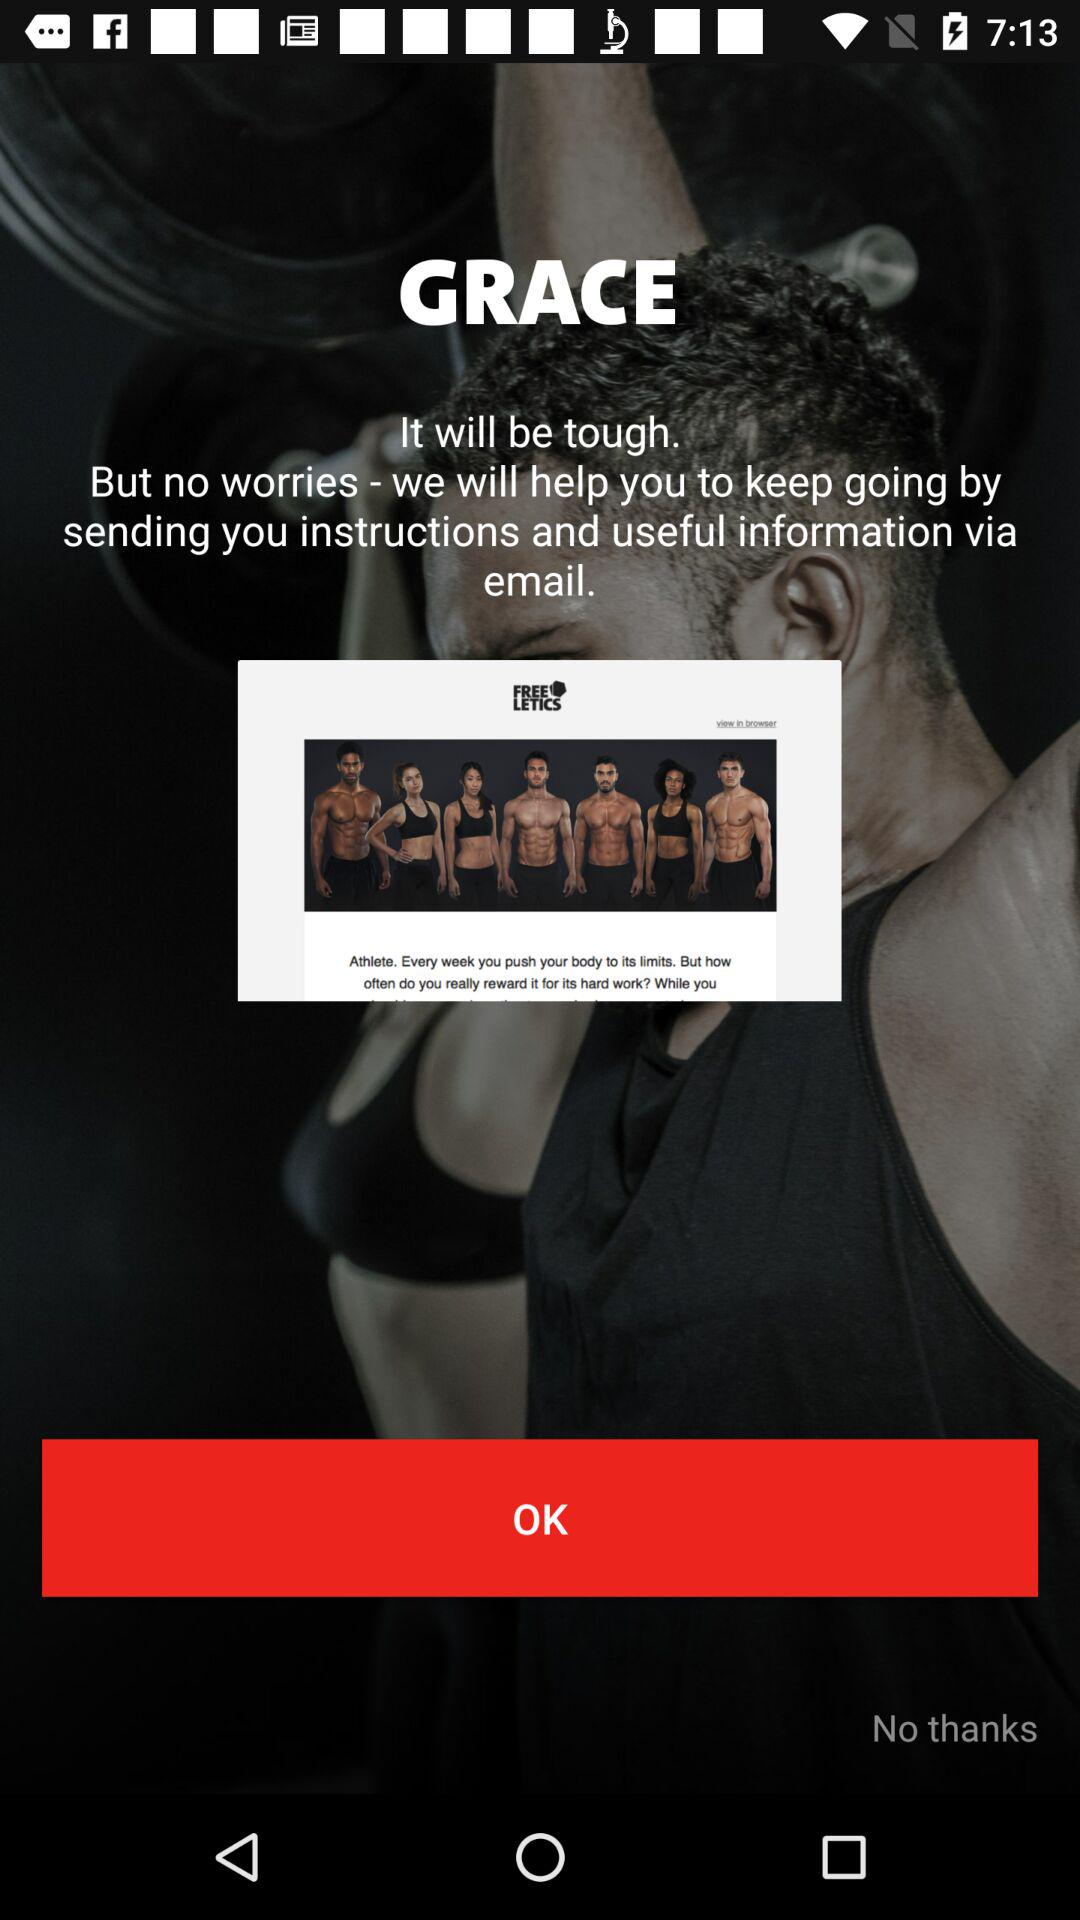What is the application name? The application name is "FREE LETICS". 